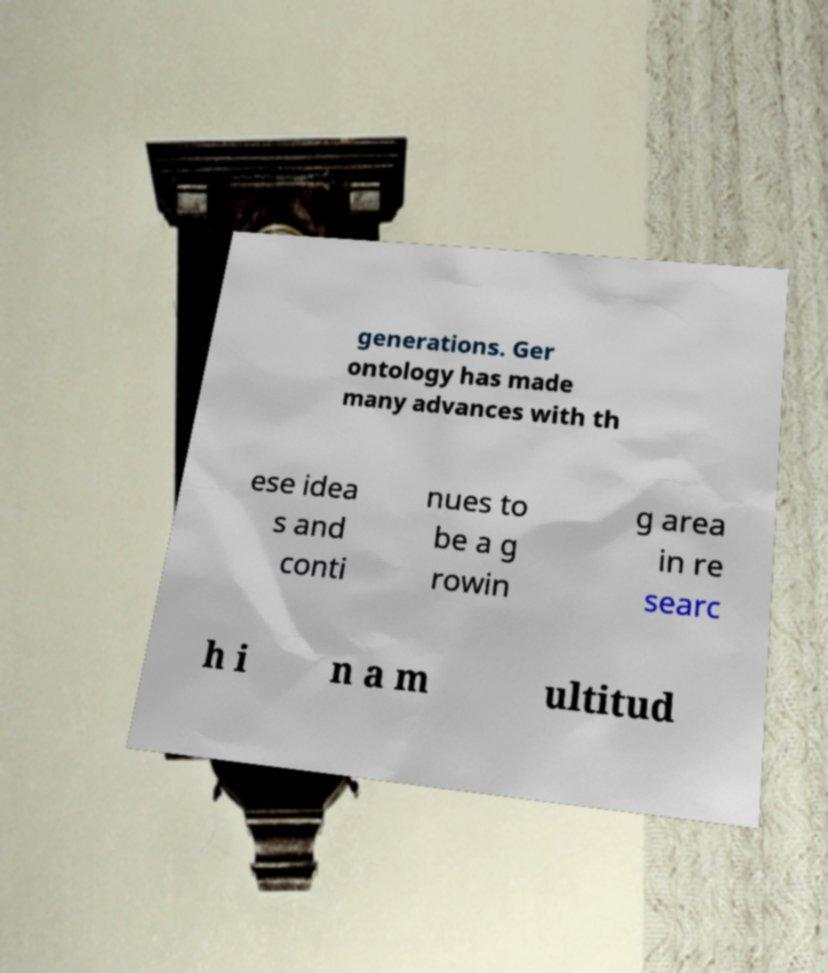Can you read and provide the text displayed in the image?This photo seems to have some interesting text. Can you extract and type it out for me? generations. Ger ontology has made many advances with th ese idea s and conti nues to be a g rowin g area in re searc h i n a m ultitud 